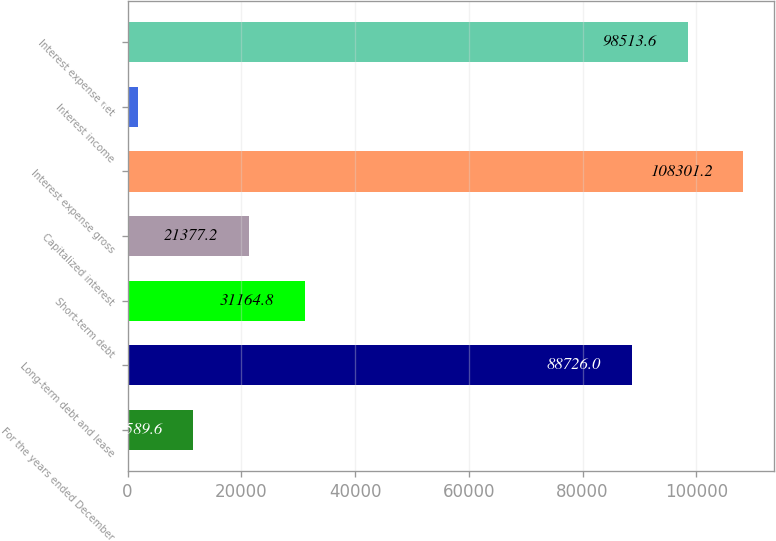Convert chart to OTSL. <chart><loc_0><loc_0><loc_500><loc_500><bar_chart><fcel>For the years ended December<fcel>Long-term debt and lease<fcel>Short-term debt<fcel>Capitalized interest<fcel>Interest expense gross<fcel>Interest income<fcel>Interest expense net<nl><fcel>11589.6<fcel>88726<fcel>31164.8<fcel>21377.2<fcel>108301<fcel>1802<fcel>98513.6<nl></chart> 